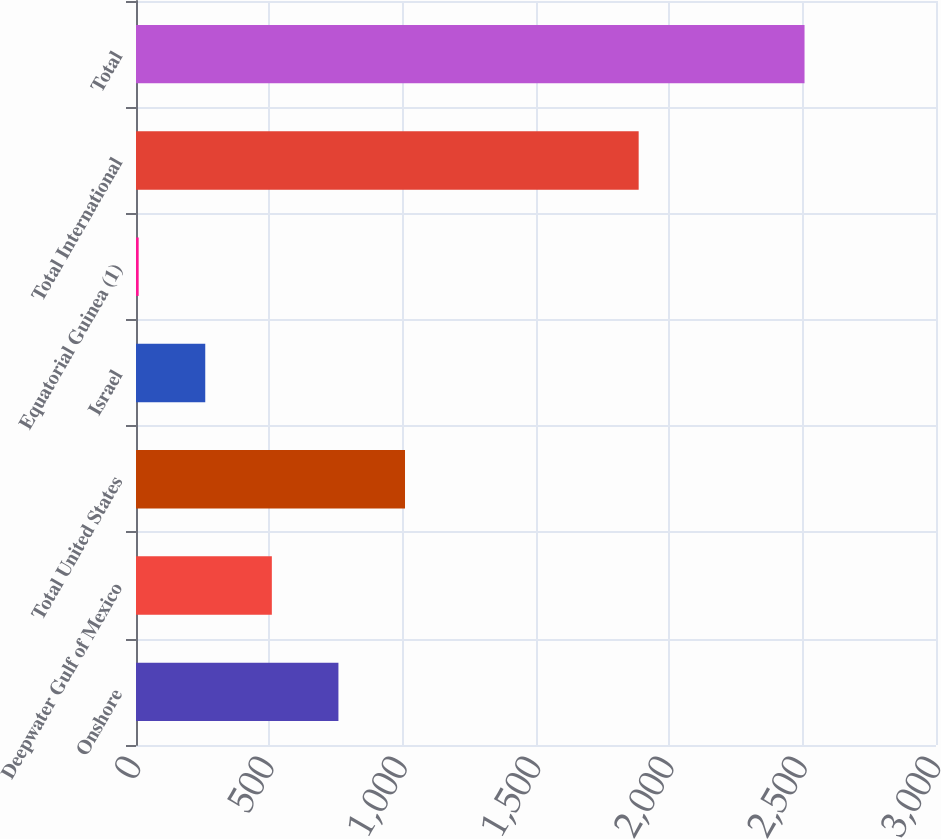<chart> <loc_0><loc_0><loc_500><loc_500><bar_chart><fcel>Onshore<fcel>Deepwater Gulf of Mexico<fcel>Total United States<fcel>Israel<fcel>Equatorial Guinea (1)<fcel>Total International<fcel>Total<nl><fcel>759.1<fcel>509.4<fcel>1008.8<fcel>259.7<fcel>10<fcel>1885<fcel>2507<nl></chart> 